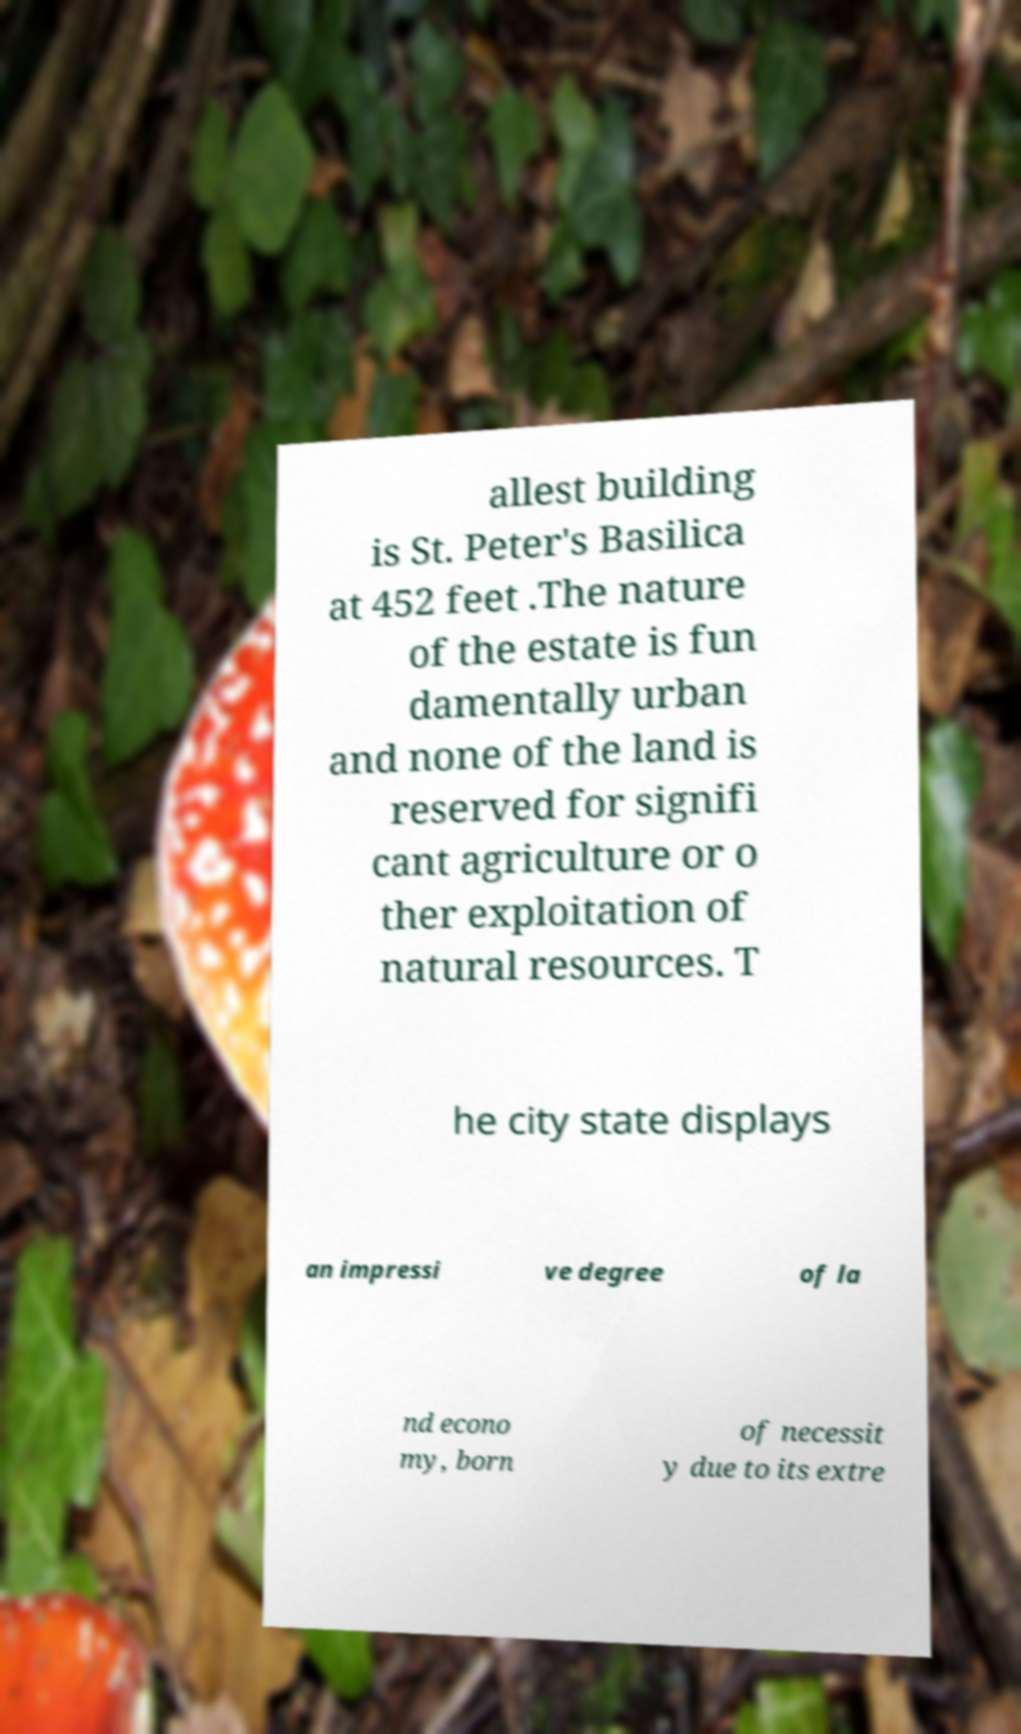Could you assist in decoding the text presented in this image and type it out clearly? allest building is St. Peter's Basilica at 452 feet .The nature of the estate is fun damentally urban and none of the land is reserved for signifi cant agriculture or o ther exploitation of natural resources. T he city state displays an impressi ve degree of la nd econo my, born of necessit y due to its extre 